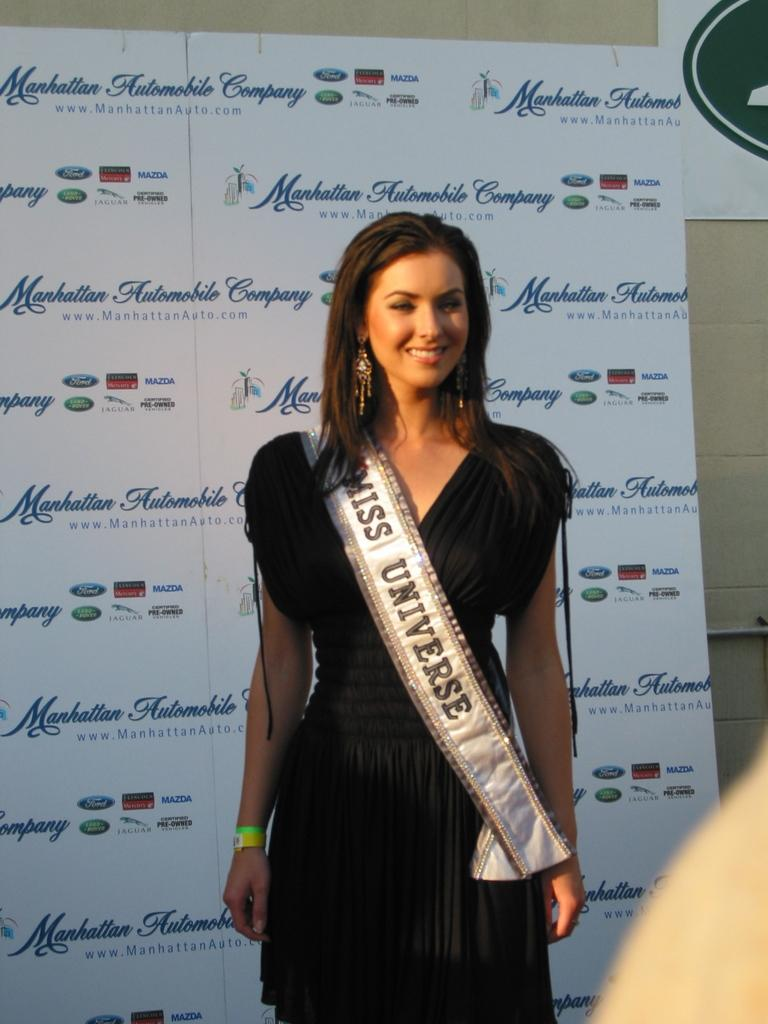What is the woman in the image wearing? The woman is wearing a black dress. What can be seen in the image related to a beauty pageant? There is an object with "Miss Universe" written on it in the image. What else is present in the image with writing on it? There is a banner in the image with writing on it. What type of discussion is the woman having with her partner in the image? There is no partner present in the image, and no discussion can be observed. 